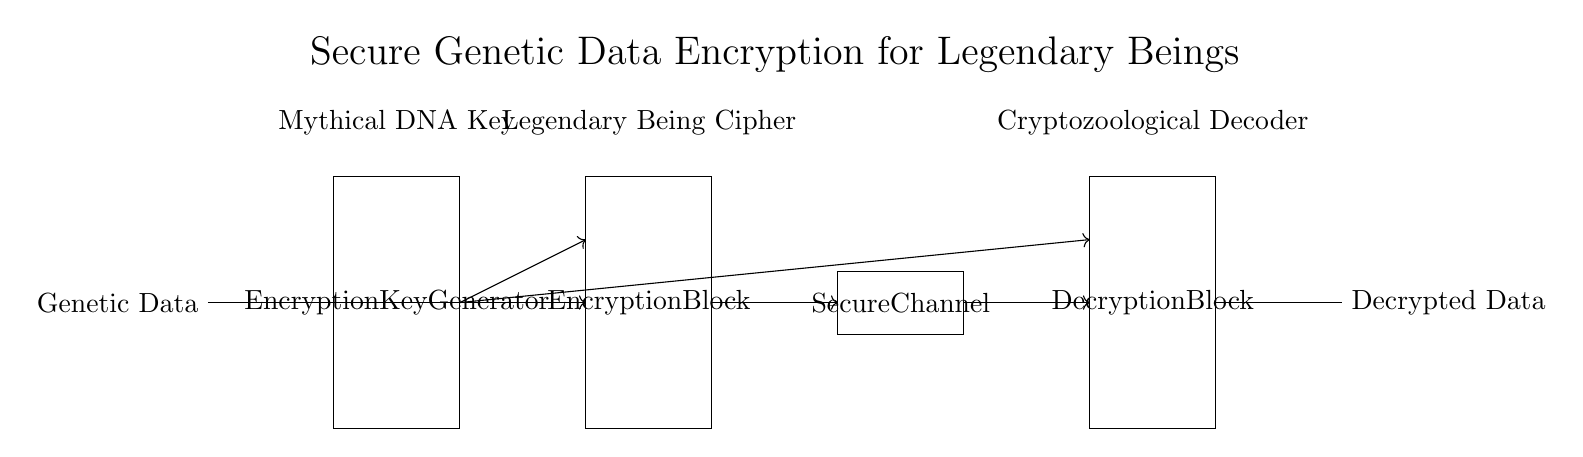What is the main purpose of the circuit? The main purpose of the circuit is to secure the transmission of genetic data related to legendary beings through encryption and decryption processes.
Answer: Secure genetic data transmission What component generates the encryption key? The component that generates the encryption key is labeled as the "Encryption Key Generator," which is indicated by the rectangle in the circuit diagram.
Answer: Encryption Key Generator How many blocks are there for data processing in this circuit? There are four blocks: the Encryption Key Generator, the Encryption Block, the Decryption Block, and the Secure Channel, as represented by the labeled rectangles in the diagram.
Answer: Four What type of data does the circuit input? The circuit inputs "Genetic Data," which is specified at the starting point on the left side of the circuit diagram.
Answer: Genetic Data Which component secures the transmission channel? The component that secures the transmission channel is labeled as "Secure Channel," which appears as a rectangle in the middle of the circuit diagram.
Answer: Secure Channel What type of data is produced as output from the circuit? The output data from the circuit is labeled as "Decrypted Data," which indicates the final processed information after going through the decryption block.
Answer: Decrypted Data What is the designation of the component processing the decrypted output? The component processing the decrypted output is designated as "Cryptozoological Decoder," which is written above the Decryption Block in the circuit diagram.
Answer: Cryptozoological Decoder 